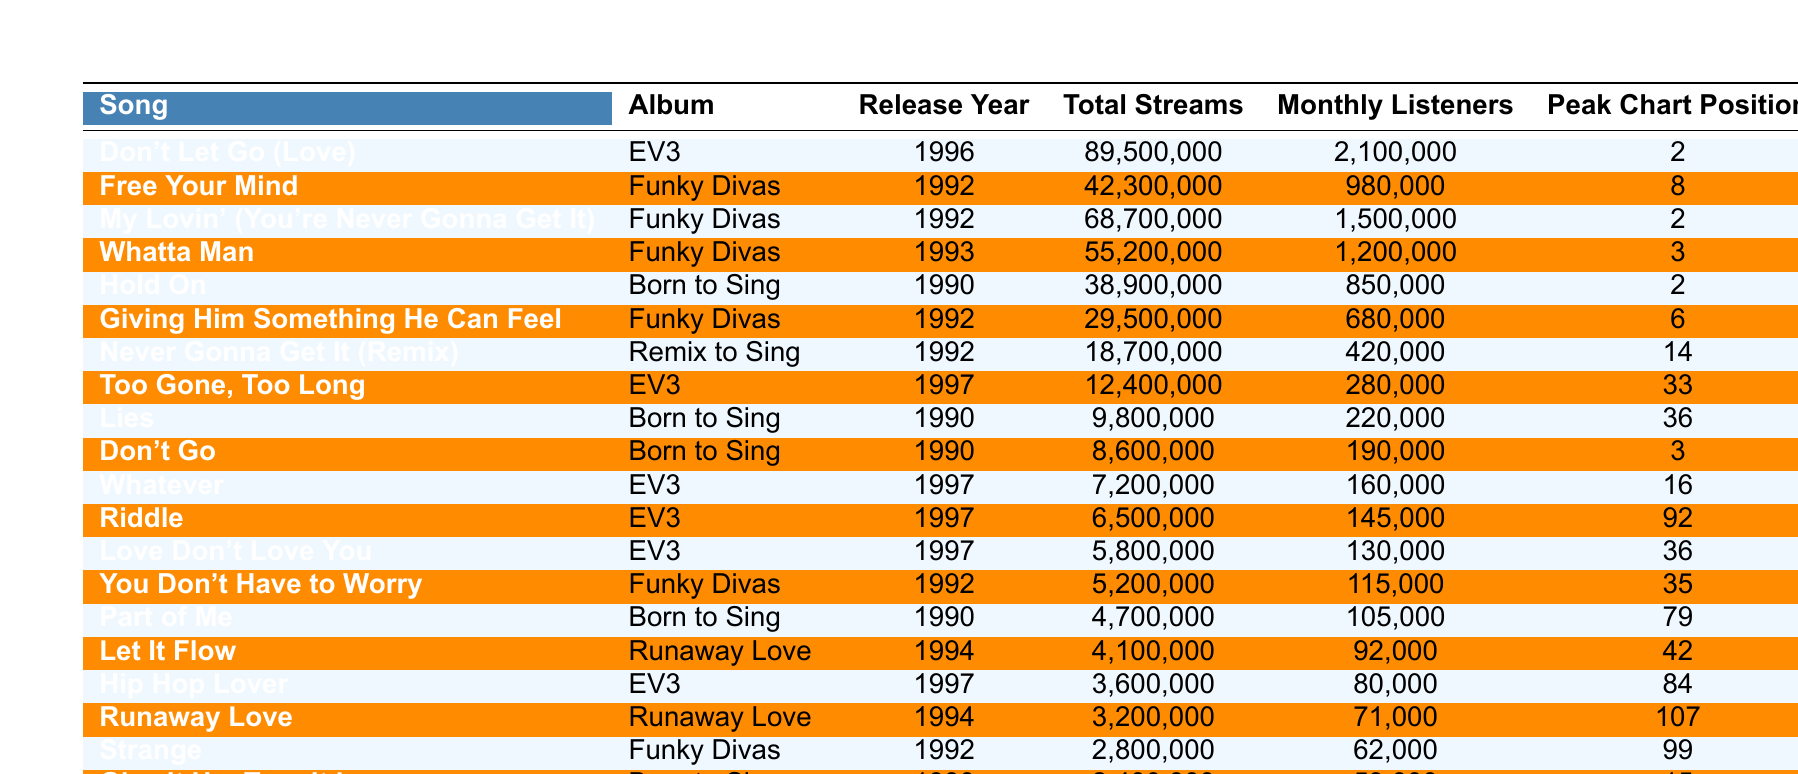What song has the highest total streams? By examining the "Total Streams" column, "Don't Let Go (Love)" has the highest value of 89,500,000 streams.
Answer: Don't Let Go (Love) Which song peaked at the highest chart position? The "Peak Chart Position" column shows that "Don't Let Go (Love)" peaked at position 2, which is the highest compared to other songs in the table.
Answer: Don't Let Go (Love) What is the total number of monthly listeners for "Free Your Mind"? The "Monthly Listeners" column shows that "Free Your Mind" has 980,000 monthly listeners.
Answer: 980,000 How many songs were released in 1997? By counting the entries with "Release Year" equal to 1997, we find there are 4 songs released in that year: "Too Gone, Too Long", "Whatever", "Hip Hop Lover", and "Riddle".
Answer: 4 What is the average total streams of the songs released in 1992? The songs released in 1992 are "Free Your Mind", "My Lovin' (You're Never Gonna Get It)", "Whatta Man", "Giving Him Something He Can Feel", "Never Gonna Get It (Remix)", and "You Don't Have to Worry". Their total streams are 42,300,000 + 68,700,000 + 55,200,000 + 29,500,000 + 18,700,000 + 5,200,000 = 219,600,000. There are 6 songs, so the average is 219,600,000 / 6 = 36,600,000.
Answer: 36,600,000 Which album contains the song with the lowest total streams? "Give It Up, Turn It Loose" has the lowest total streams of 2,400,000 and is featured in the "Born to Sing" album.
Answer: Born to Sing Is "Riddle" among the top 5 songs by total streams? By comparing "Riddle's" total streams of 6,500,000 to the top 5 highest values in the "Total Streams" column, we find that it is not included in the top 5.
Answer: No What song would you expect to be more popular based on streams: "Too Gone, Too Long" or "Don't Go"? "Too Gone, Too Long" has 12,400,000 streams while "Don't Go" has 8,600,000. Therefore, "Too Gone, Too Long" is more popular based on streams.
Answer: Too Gone, Too Long How many monthly listeners does the song "My Lovin' (You're Never Gonna Get It)" have compared to "Hip Hop Lover"? "My Lovin' (You're Never Gonna Get It)" has 1,500,000 monthly listeners, while "Hip Hop Lover" has 80,000. The difference is 1,500,000 - 80,000 = 1,420,000.
Answer: 1,420,000 What is the total number of streams for songs from the "Funky Divas" album? The songs from the "Funky Divas" album are "Free Your Mind", "My Lovin' (You're Never Gonna Get It)", "Whatta Man", "Giving Him Something He Can Feel", "Never Gonna Get It (Remix)", and "You Don't Have to Worry". Adding their total streams gives 42,300,000 + 68,700,000 + 55,200,000 + 29,500,000 + 18,700,000 + 5,200,000 = 219,600,000.
Answer: 219,600,000 Which song was released first in the 1990s? "Hold On" was released in 1990, which is earlier than any other song listed in the table.
Answer: Hold On 